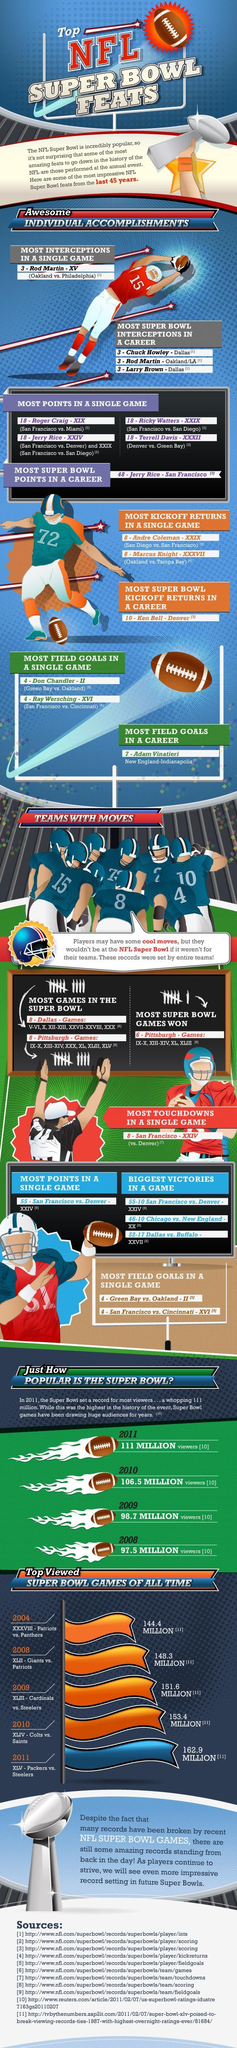How many players from Dallas got the recognition for most super bowl interceptions?
Answer the question with a short phrase. 2 In which match Ricky Watters got the greatest points in a single game? San Francisco vs. San Diego In which match Terrell got the greatest points in a single game? Denver Vs. Green Bay In which year second-largest no of people watched Super Bowl matches? 2010 What is the name of the second player from Dallas who got the recognition for most super bowl interceptions? Larry Brown 